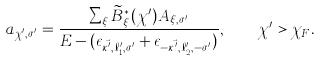Convert formula to latex. <formula><loc_0><loc_0><loc_500><loc_500>a _ { \chi ^ { \prime } , \sigma ^ { \prime } } = \frac { \sum _ { \xi } \widetilde { B } ^ { \ast } _ { \xi } ( \chi ^ { \prime } ) A _ { \xi , \sigma ^ { \prime } } } { E - ( \epsilon _ { \vec { \kappa ^ { \prime } } , \ell ^ { \prime } _ { 1 } , \sigma ^ { \prime } } + \epsilon _ { - \vec { \kappa ^ { \prime } } , \ell ^ { \prime } _ { 2 } , - \sigma ^ { \prime } } ) } , \quad \chi ^ { \prime } > \chi _ { F } .</formula> 